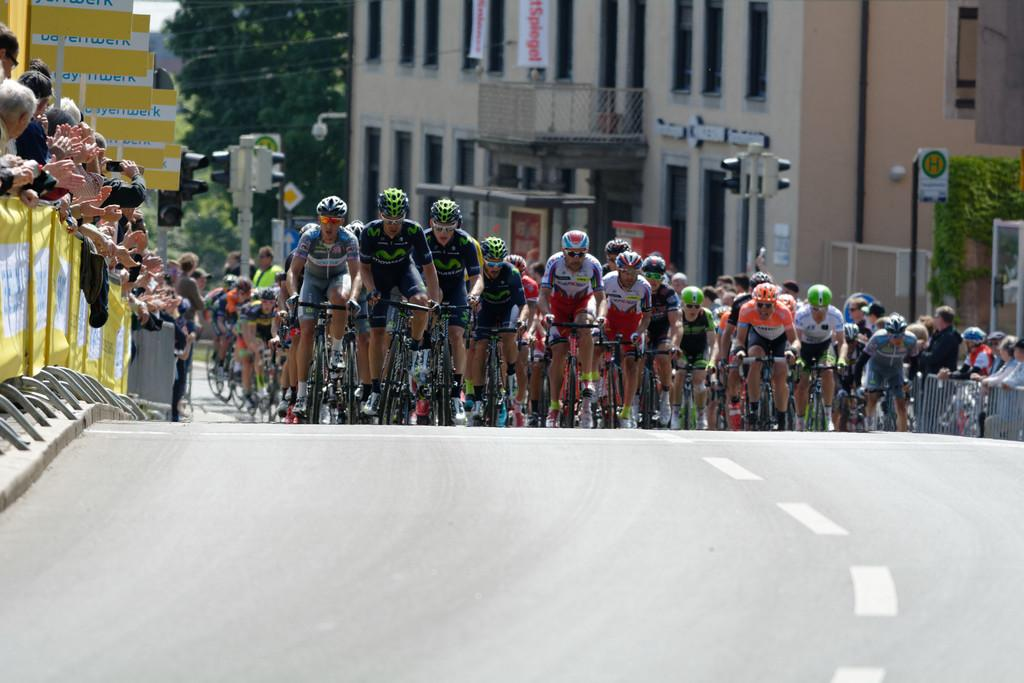What are the people in the image doing? There are people riding bicycles in the image. Are there any other activities happening in the image? Yes, some people are standing and taking pictures. What can be seen in the background of the image? There are buildings visible in the background. What type of hope can be seen in the image? There is no hope present in the image; it features people riding bicycles and taking pictures. Can you tell me where the maid is located in the image? There is no maid present in the image. 